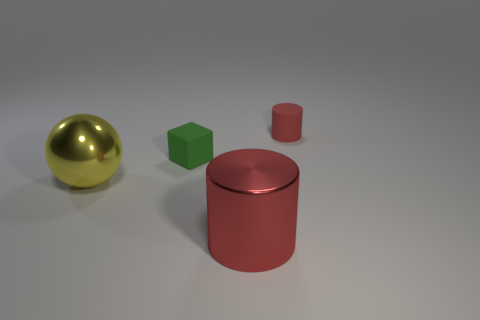Is the material of the tiny thing that is in front of the tiny red rubber thing the same as the yellow thing that is behind the red metallic thing?
Your answer should be compact. No. What is the color of the matte thing left of the small object to the right of the big shiny thing on the right side of the large yellow metal thing?
Your response must be concise. Green. What number of other objects are the same shape as the tiny green matte object?
Keep it short and to the point. 0. Is the rubber block the same color as the tiny cylinder?
Keep it short and to the point. No. What number of things are small red cylinders or big metal things right of the green object?
Offer a very short reply. 2. Are there any yellow rubber things of the same size as the yellow metallic thing?
Your response must be concise. No. Does the large red object have the same material as the large yellow ball?
Your answer should be compact. Yes. What number of things are big blue objects or small red things?
Keep it short and to the point. 1. What is the size of the yellow ball?
Offer a very short reply. Large. Is the number of yellow balls less than the number of yellow metal cylinders?
Ensure brevity in your answer.  No. 